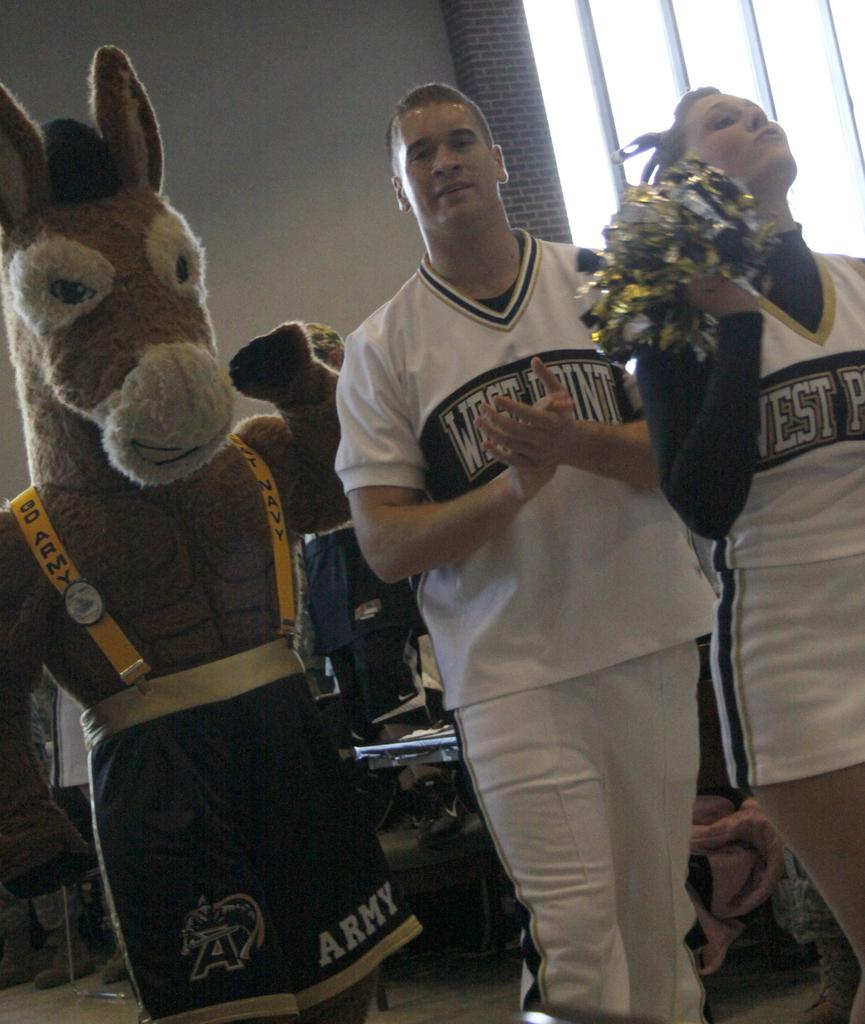What is written on the donkey's shorts?
Offer a very short reply. Army. What american military academy is written on the shirts?
Make the answer very short. West point. 